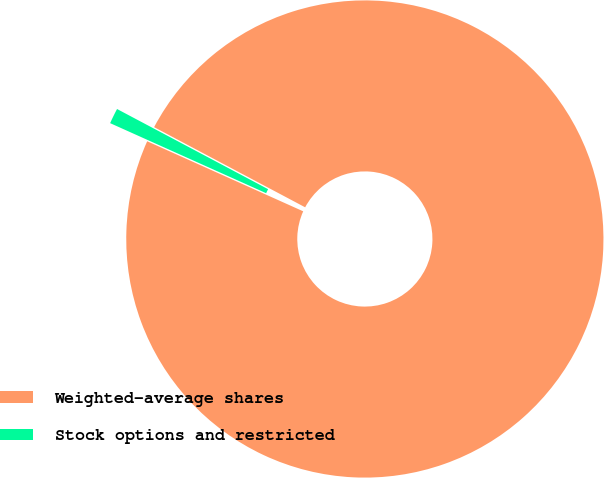Convert chart to OTSL. <chart><loc_0><loc_0><loc_500><loc_500><pie_chart><fcel>Weighted-average shares<fcel>Stock options and restricted<nl><fcel>98.95%<fcel>1.05%<nl></chart> 